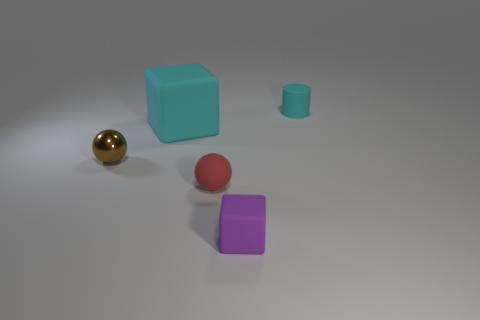How many objects are there in the image, and can you categorize them by their shapes? I count a total of five objects in the image. They can be categorized by shape as follows: two cubes (one cyan, one purple), two spheres (one gold, one red), and one cylinder (grey). 